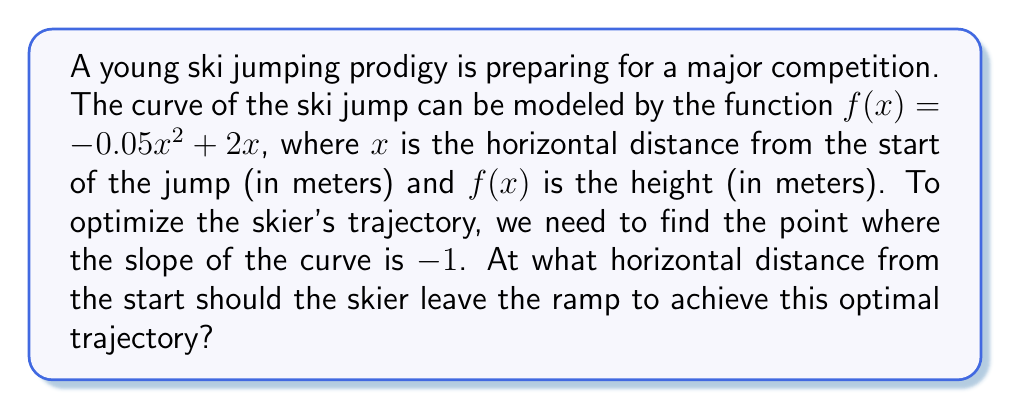Provide a solution to this math problem. To solve this problem, we'll follow these steps:

1) The slope of the curve at any point is given by the derivative of the function. Let's find $f'(x)$:

   $f(x) = -0.05x^2 + 2x$
   $f'(x) = -0.1x + 2$

2) We want to find the point where the slope is -1, so we set up the equation:

   $f'(x) = -1$
   $-0.1x + 2 = -1$

3) Solve the equation:

   $-0.1x + 2 = -1$
   $-0.1x = -3$
   $x = 30$

4) To verify, we can check the second derivative to ensure it's negative, confirming this is the optimal point:

   $f''(x) = -0.1$, which is indeed negative.

Therefore, the skier should leave the ramp 30 meters from the start to achieve the optimal trajectory.
Answer: 30 meters 